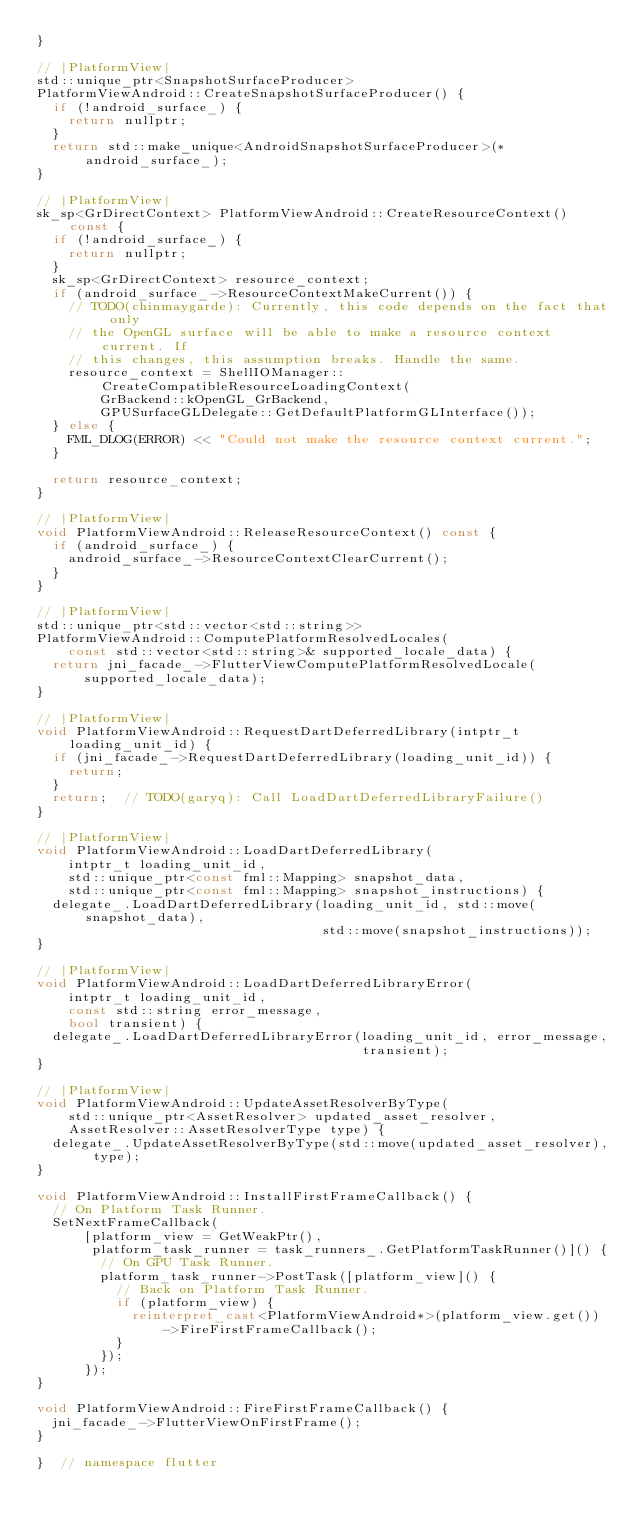Convert code to text. <code><loc_0><loc_0><loc_500><loc_500><_C++_>}

// |PlatformView|
std::unique_ptr<SnapshotSurfaceProducer>
PlatformViewAndroid::CreateSnapshotSurfaceProducer() {
  if (!android_surface_) {
    return nullptr;
  }
  return std::make_unique<AndroidSnapshotSurfaceProducer>(*android_surface_);
}

// |PlatformView|
sk_sp<GrDirectContext> PlatformViewAndroid::CreateResourceContext() const {
  if (!android_surface_) {
    return nullptr;
  }
  sk_sp<GrDirectContext> resource_context;
  if (android_surface_->ResourceContextMakeCurrent()) {
    // TODO(chinmaygarde): Currently, this code depends on the fact that only
    // the OpenGL surface will be able to make a resource context current. If
    // this changes, this assumption breaks. Handle the same.
    resource_context = ShellIOManager::CreateCompatibleResourceLoadingContext(
        GrBackend::kOpenGL_GrBackend,
        GPUSurfaceGLDelegate::GetDefaultPlatformGLInterface());
  } else {
    FML_DLOG(ERROR) << "Could not make the resource context current.";
  }

  return resource_context;
}

// |PlatformView|
void PlatformViewAndroid::ReleaseResourceContext() const {
  if (android_surface_) {
    android_surface_->ResourceContextClearCurrent();
  }
}

// |PlatformView|
std::unique_ptr<std::vector<std::string>>
PlatformViewAndroid::ComputePlatformResolvedLocales(
    const std::vector<std::string>& supported_locale_data) {
  return jni_facade_->FlutterViewComputePlatformResolvedLocale(
      supported_locale_data);
}

// |PlatformView|
void PlatformViewAndroid::RequestDartDeferredLibrary(intptr_t loading_unit_id) {
  if (jni_facade_->RequestDartDeferredLibrary(loading_unit_id)) {
    return;
  }
  return;  // TODO(garyq): Call LoadDartDeferredLibraryFailure()
}

// |PlatformView|
void PlatformViewAndroid::LoadDartDeferredLibrary(
    intptr_t loading_unit_id,
    std::unique_ptr<const fml::Mapping> snapshot_data,
    std::unique_ptr<const fml::Mapping> snapshot_instructions) {
  delegate_.LoadDartDeferredLibrary(loading_unit_id, std::move(snapshot_data),
                                    std::move(snapshot_instructions));
}

// |PlatformView|
void PlatformViewAndroid::LoadDartDeferredLibraryError(
    intptr_t loading_unit_id,
    const std::string error_message,
    bool transient) {
  delegate_.LoadDartDeferredLibraryError(loading_unit_id, error_message,
                                         transient);
}

// |PlatformView|
void PlatformViewAndroid::UpdateAssetResolverByType(
    std::unique_ptr<AssetResolver> updated_asset_resolver,
    AssetResolver::AssetResolverType type) {
  delegate_.UpdateAssetResolverByType(std::move(updated_asset_resolver), type);
}

void PlatformViewAndroid::InstallFirstFrameCallback() {
  // On Platform Task Runner.
  SetNextFrameCallback(
      [platform_view = GetWeakPtr(),
       platform_task_runner = task_runners_.GetPlatformTaskRunner()]() {
        // On GPU Task Runner.
        platform_task_runner->PostTask([platform_view]() {
          // Back on Platform Task Runner.
          if (platform_view) {
            reinterpret_cast<PlatformViewAndroid*>(platform_view.get())
                ->FireFirstFrameCallback();
          }
        });
      });
}

void PlatformViewAndroid::FireFirstFrameCallback() {
  jni_facade_->FlutterViewOnFirstFrame();
}

}  // namespace flutter
</code> 